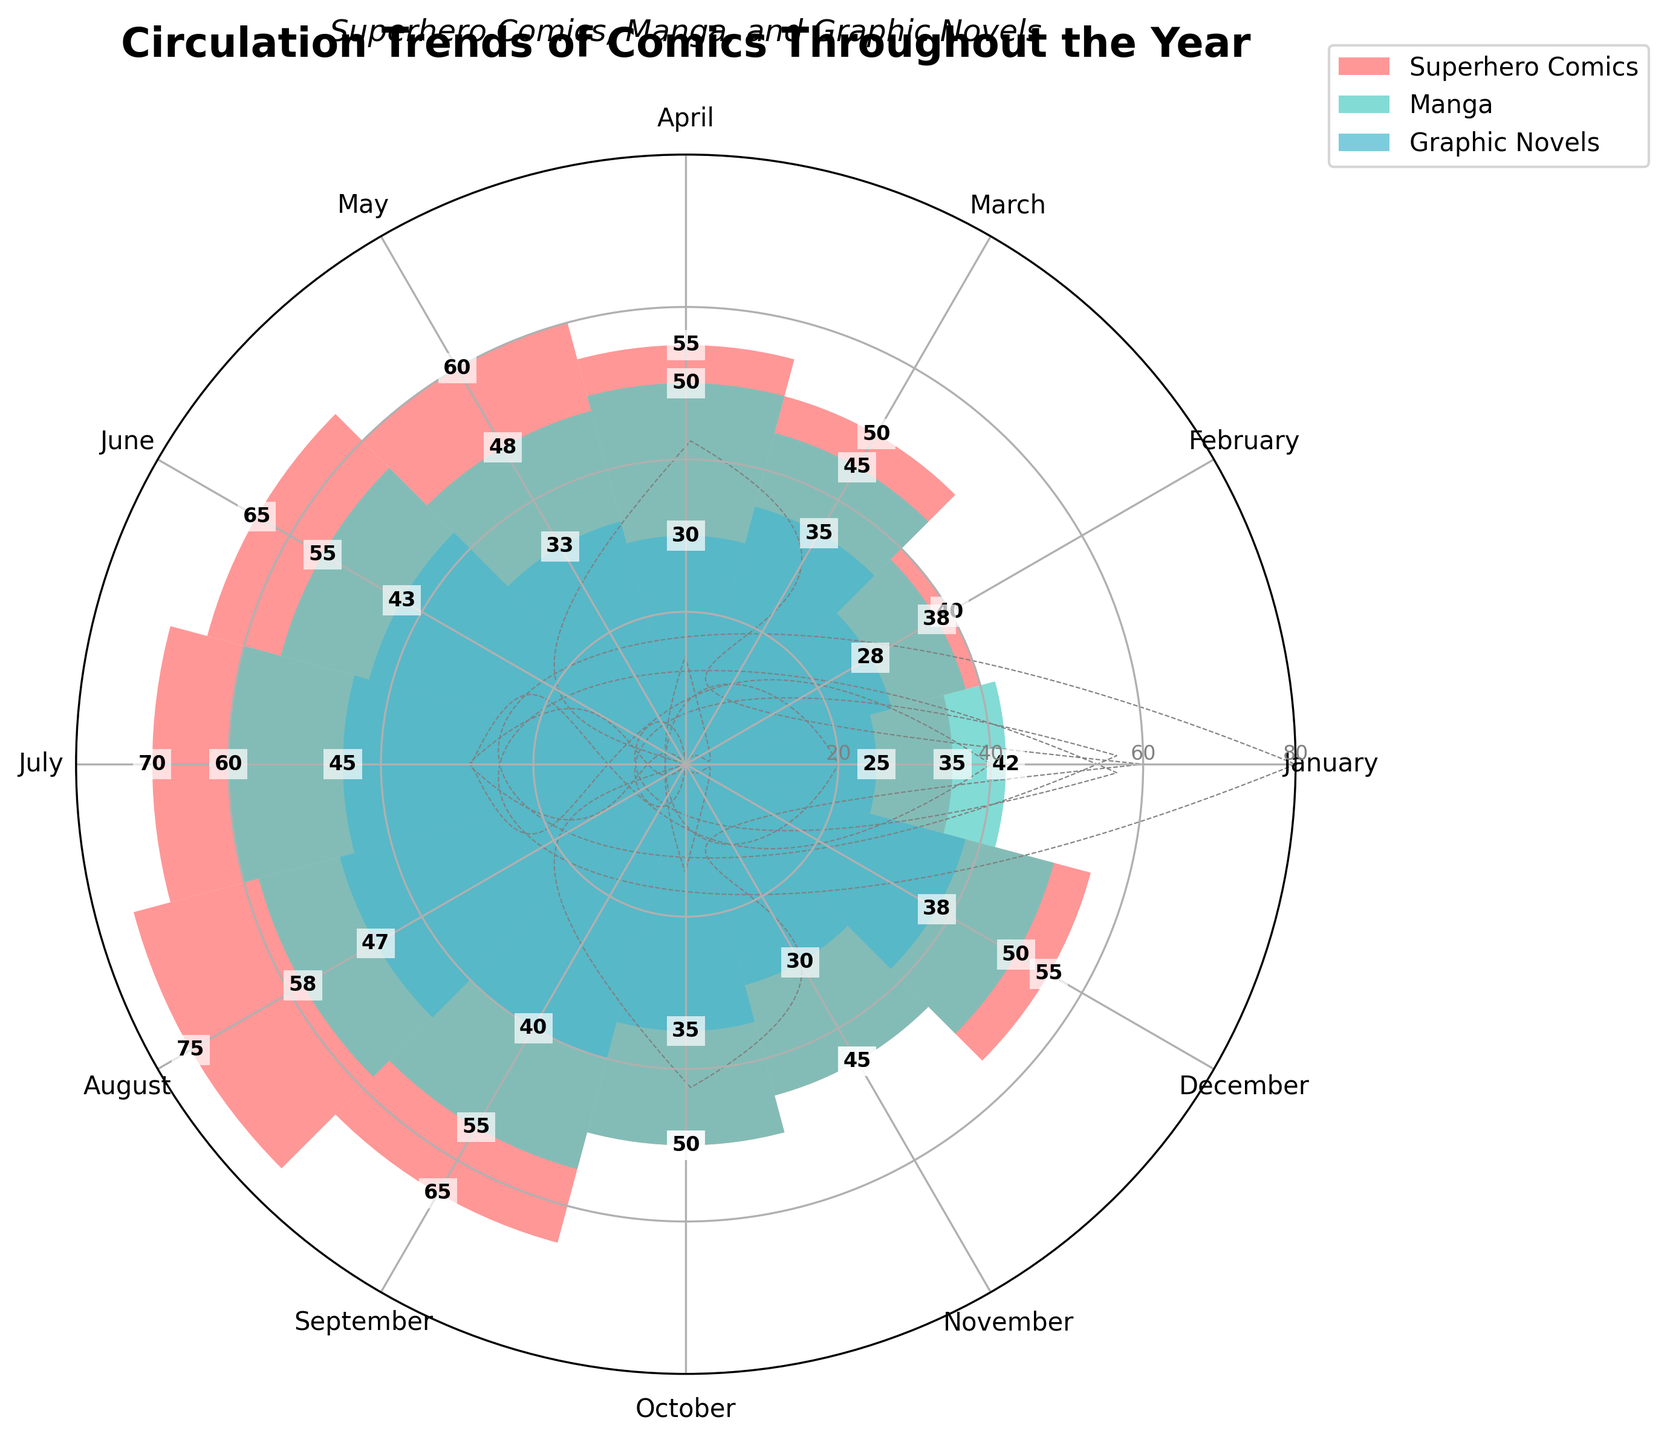What is the title of the rose chart? The title can be found at the top of the chart. It usually provides a brief description of the chart’s content.
Answer: Circulation Trends of Comics Throughout the Year Which month has the highest circulation of Manga? To find the answer, look at the section labeled "Manga" and identify the month with the tallest bar in that section.
Answer: July How many groups are represented in the rose chart? Count the number of different colored bar groups in the chart's legend. There should be three distinct colors corresponding to three groups.
Answer: 3 Which type of comics had the highest circulation in March? To answer this, compare the height of the bars for each comic type in the month of March. The tallest bar indicates the highest circulation.
Answer: Manga What is the average circulation of Superhero Comics in the first quarter (January to March)? First, sum the circulation numbers for Superhero Comics in January, February, and March. Then divide by 3 (the number of months). Calculation: (35 + 40 + 50) / 3 = 125 / 3
Answer: 41.67 In which month did Graphic Novels have the same circulation as Manga? Compare the heights of the bars for Graphic Novels and Manga across all months to find when they are equal. Both bars should be at the same level for that month.
Answer: October How does the circulation of Superhero Comics in May compare to that in November? Compare the height of the Superhero Comics bars in May and November. Look for which one is taller or if they are equal.
Answer: May is higher What is the total circulation of comics in June? Sum the values for all three comic types in June. Calculation: 65 (Superhero Comics) + 55 (Manga) + 43 (Graphic Novels)
Answer: 163 Which type of comic saw an increase in circulation every month from January to July? Observe the trend for each comic type from January to July. Check if one of them consistently increases each month.
Answer: Superhero Comics Identify the month with the lowest circulation of Graphic Novels. Identify the shortest bar in the Graphic Novels section to find the month with the lowest circulation.
Answer: January 